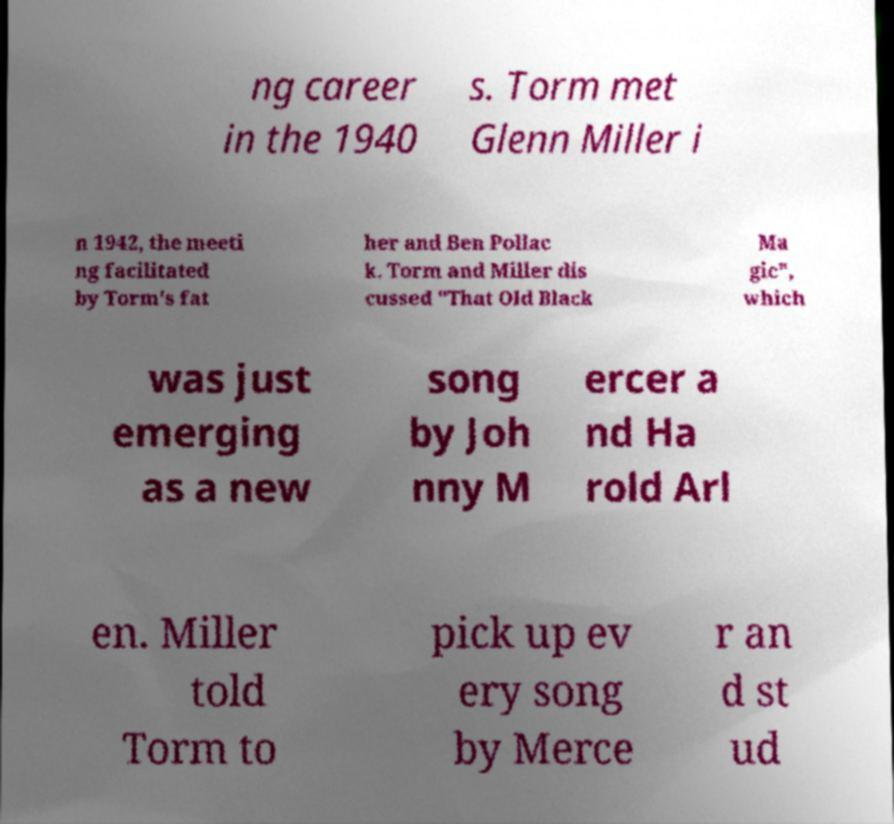Please identify and transcribe the text found in this image. ng career in the 1940 s. Torm met Glenn Miller i n 1942, the meeti ng facilitated by Torm's fat her and Ben Pollac k. Torm and Miller dis cussed "That Old Black Ma gic", which was just emerging as a new song by Joh nny M ercer a nd Ha rold Arl en. Miller told Torm to pick up ev ery song by Merce r an d st ud 